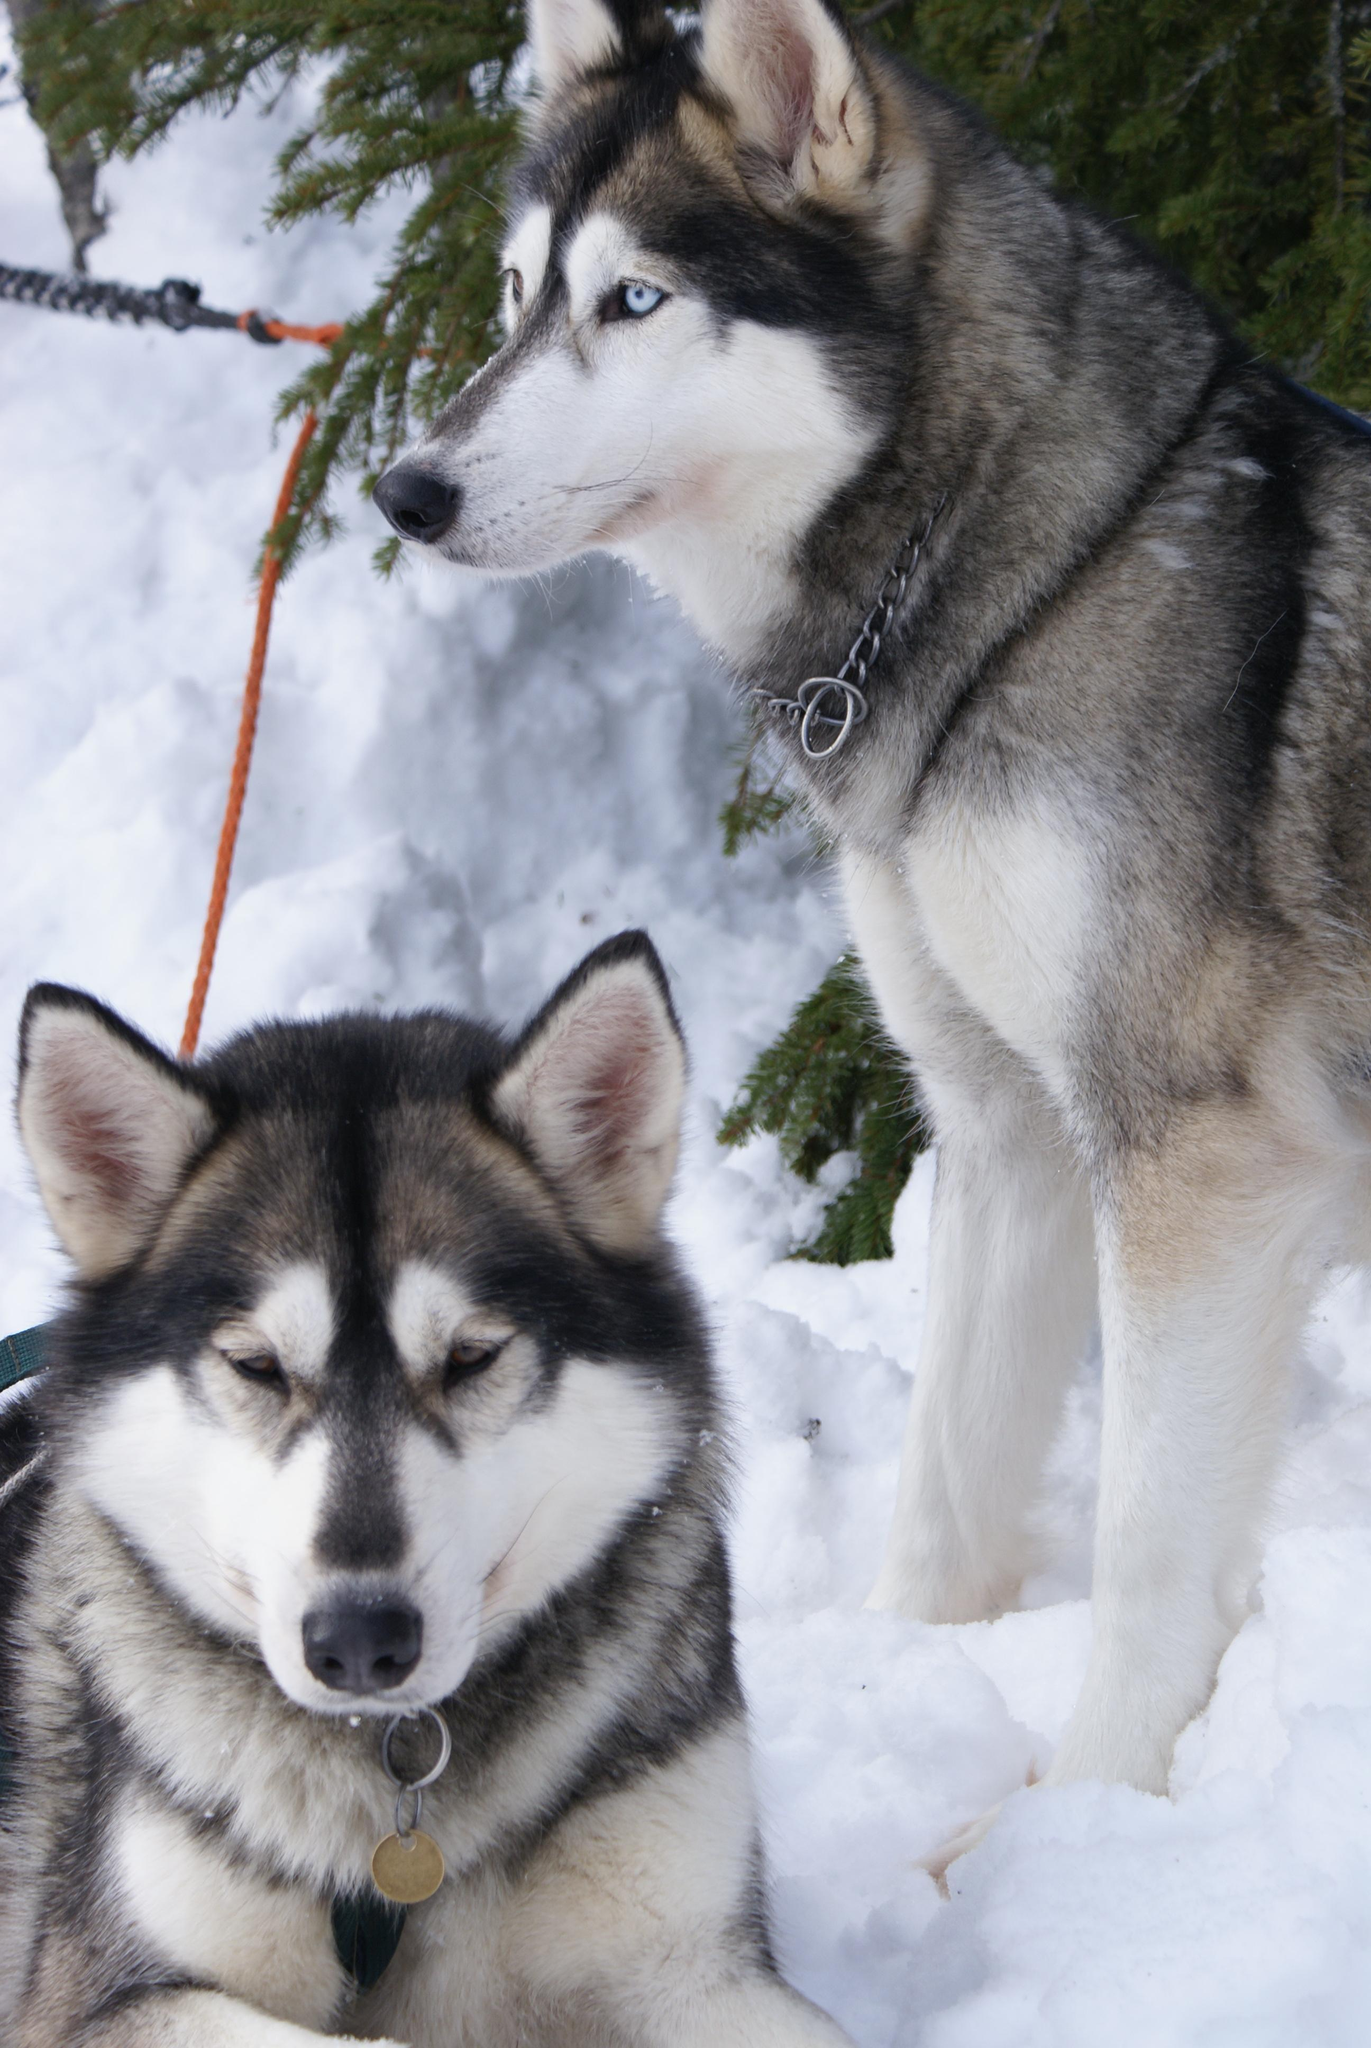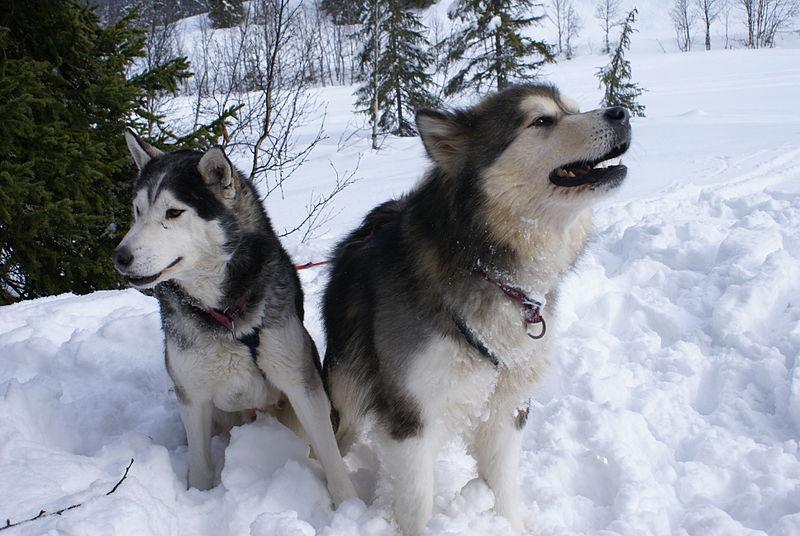The first image is the image on the left, the second image is the image on the right. For the images displayed, is the sentence "The left and right images contain pairs of husky dogs in the snow, and at least some dogs are 'hitched' with ropes." factually correct? Answer yes or no. Yes. The first image is the image on the left, the second image is the image on the right. Given the left and right images, does the statement "The left image contains two dogs surrounded by snow." hold true? Answer yes or no. Yes. 